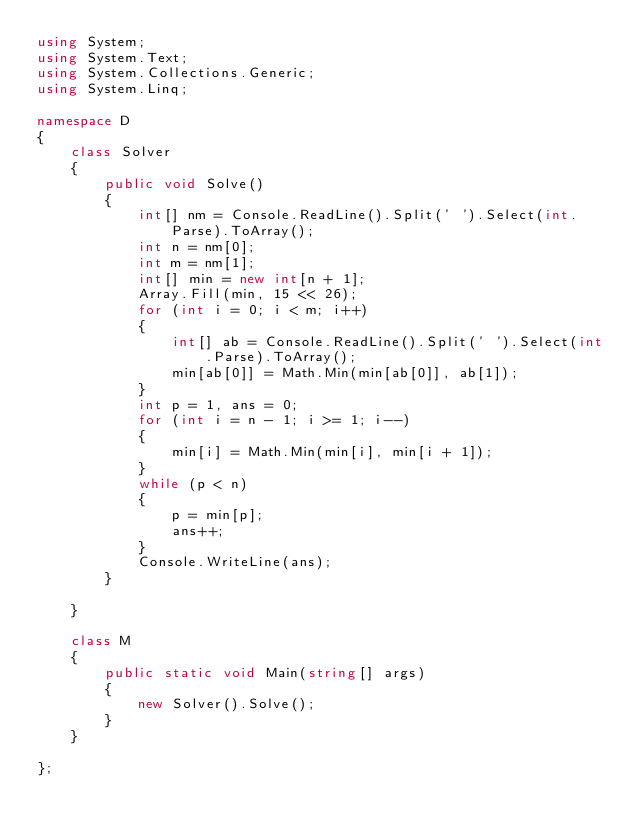Convert code to text. <code><loc_0><loc_0><loc_500><loc_500><_C#_>using System;
using System.Text;
using System.Collections.Generic;
using System.Linq;

namespace D
{
    class Solver
    {
        public void Solve()
        {
            int[] nm = Console.ReadLine().Split(' ').Select(int.Parse).ToArray();
            int n = nm[0];
            int m = nm[1];
            int[] min = new int[n + 1];
            Array.Fill(min, 15 << 26);
            for (int i = 0; i < m; i++)
            {
                int[] ab = Console.ReadLine().Split(' ').Select(int.Parse).ToArray();
                min[ab[0]] = Math.Min(min[ab[0]], ab[1]);
            }
            int p = 1, ans = 0;
            for (int i = n - 1; i >= 1; i--)
            {
                min[i] = Math.Min(min[i], min[i + 1]);
            }
            while (p < n)
            {
                p = min[p];
                ans++;
            }
            Console.WriteLine(ans);
        }

    }

    class M
    {
        public static void Main(string[] args)
        {
            new Solver().Solve();
        }
    }

};
</code> 